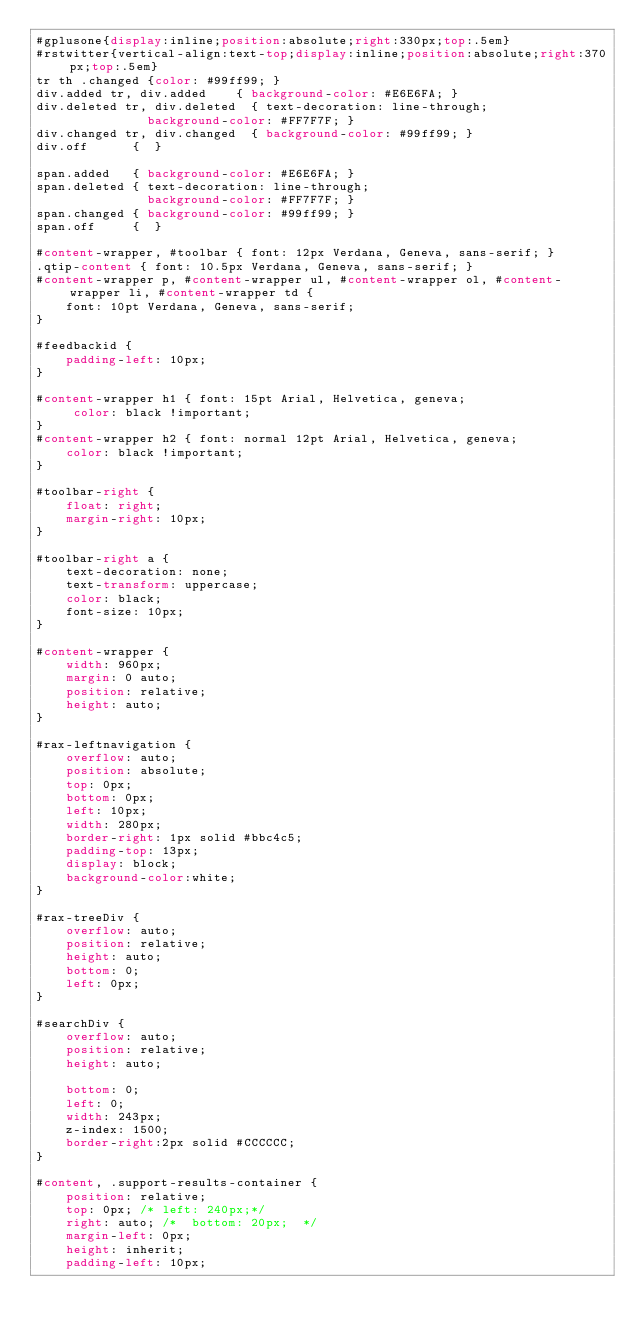Convert code to text. <code><loc_0><loc_0><loc_500><loc_500><_CSS_>#gplusone{display:inline;position:absolute;right:330px;top:.5em}
#rstwitter{vertical-align:text-top;display:inline;position:absolute;right:370px;top:.5em}
tr th .changed {color: #99ff99; }
div.added tr, div.added    { background-color: #E6E6FA; }
div.deleted tr, div.deleted  { text-decoration: line-through;
               background-color: #FF7F7F; }
div.changed tr, div.changed  { background-color: #99ff99; }
div.off      {  }

span.added   { background-color: #E6E6FA; }
span.deleted { text-decoration: line-through;
               background-color: #FF7F7F; }
span.changed { background-color: #99ff99; }
span.off     {  }

#content-wrapper, #toolbar { font: 12px Verdana, Geneva, sans-serif; }
.qtip-content { font: 10.5px Verdana, Geneva, sans-serif; }
#content-wrapper p, #content-wrapper ul, #content-wrapper ol, #content-wrapper li, #content-wrapper td { 
    font: 10pt Verdana, Geneva, sans-serif; 
}

#feedbackid {
    padding-left: 10px;
}

#content-wrapper h1 { font: 15pt Arial, Helvetica, geneva;
     color: black !important;
}
#content-wrapper h2 { font: normal 12pt Arial, Helvetica, geneva;
	color: black !important;
}

#toolbar-right {
	float: right;
	margin-right: 10px;
}

#toolbar-right a {
	text-decoration: none;
	text-transform: uppercase;
	color: black;
	font-size: 10px;
}

#content-wrapper {
    width: 960px;
    margin: 0 auto;
    position: relative;
    height: auto;
}

#rax-leftnavigation {
    overflow: auto;
    position: absolute;
    top: 0px;    
    bottom: 0px;
    left: 10px;
    width: 280px;
    border-right: 1px solid #bbc4c5;
    padding-top: 13px;
    display: block;
    background-color:white;
}

#rax-treeDiv {
    overflow: auto;
    position: relative;
    height: auto;
    bottom: 0;
    left: 0px;
}

#searchDiv {
    overflow: auto;
    position: relative;
    height: auto;
 
    bottom: 0;
    left: 0;
    width: 243px;
    z-index: 1500;
    border-right:2px solid #CCCCCC;
}

#content, .support-results-container {
    position: relative;
    top: 0px; /* left: 240px;*/
    right: auto; /*  bottom: 20px;  */
    margin-left: 0px;
    height: inherit;
    padding-left: 10px;</code> 